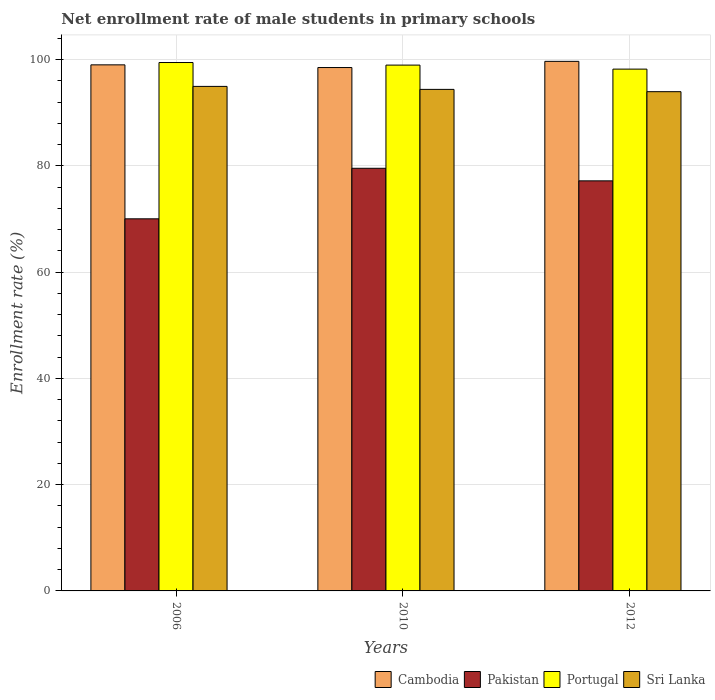How many different coloured bars are there?
Your answer should be very brief. 4. How many groups of bars are there?
Give a very brief answer. 3. Are the number of bars per tick equal to the number of legend labels?
Your answer should be very brief. Yes. How many bars are there on the 3rd tick from the left?
Your answer should be very brief. 4. How many bars are there on the 2nd tick from the right?
Your answer should be compact. 4. In how many cases, is the number of bars for a given year not equal to the number of legend labels?
Ensure brevity in your answer.  0. What is the net enrollment rate of male students in primary schools in Pakistan in 2006?
Offer a very short reply. 70.04. Across all years, what is the maximum net enrollment rate of male students in primary schools in Portugal?
Provide a succinct answer. 99.46. Across all years, what is the minimum net enrollment rate of male students in primary schools in Sri Lanka?
Make the answer very short. 93.97. In which year was the net enrollment rate of male students in primary schools in Portugal minimum?
Provide a succinct answer. 2012. What is the total net enrollment rate of male students in primary schools in Pakistan in the graph?
Offer a very short reply. 226.78. What is the difference between the net enrollment rate of male students in primary schools in Pakistan in 2006 and that in 2010?
Your response must be concise. -9.51. What is the difference between the net enrollment rate of male students in primary schools in Sri Lanka in 2010 and the net enrollment rate of male students in primary schools in Portugal in 2006?
Give a very brief answer. -5.06. What is the average net enrollment rate of male students in primary schools in Pakistan per year?
Provide a succinct answer. 75.59. In the year 2010, what is the difference between the net enrollment rate of male students in primary schools in Portugal and net enrollment rate of male students in primary schools in Sri Lanka?
Provide a succinct answer. 4.57. In how many years, is the net enrollment rate of male students in primary schools in Cambodia greater than 24 %?
Provide a succinct answer. 3. What is the ratio of the net enrollment rate of male students in primary schools in Sri Lanka in 2006 to that in 2012?
Offer a terse response. 1.01. Is the net enrollment rate of male students in primary schools in Sri Lanka in 2010 less than that in 2012?
Keep it short and to the point. No. Is the difference between the net enrollment rate of male students in primary schools in Portugal in 2010 and 2012 greater than the difference between the net enrollment rate of male students in primary schools in Sri Lanka in 2010 and 2012?
Ensure brevity in your answer.  Yes. What is the difference between the highest and the second highest net enrollment rate of male students in primary schools in Cambodia?
Provide a short and direct response. 0.66. What is the difference between the highest and the lowest net enrollment rate of male students in primary schools in Sri Lanka?
Keep it short and to the point. 0.99. Is the sum of the net enrollment rate of male students in primary schools in Sri Lanka in 2010 and 2012 greater than the maximum net enrollment rate of male students in primary schools in Cambodia across all years?
Your answer should be compact. Yes. What does the 2nd bar from the left in 2006 represents?
Ensure brevity in your answer.  Pakistan. What does the 1st bar from the right in 2010 represents?
Provide a succinct answer. Sri Lanka. Is it the case that in every year, the sum of the net enrollment rate of male students in primary schools in Portugal and net enrollment rate of male students in primary schools in Sri Lanka is greater than the net enrollment rate of male students in primary schools in Pakistan?
Keep it short and to the point. Yes. How many bars are there?
Your answer should be compact. 12. How many years are there in the graph?
Provide a short and direct response. 3. Does the graph contain any zero values?
Offer a terse response. No. What is the title of the graph?
Your response must be concise. Net enrollment rate of male students in primary schools. Does "United Arab Emirates" appear as one of the legend labels in the graph?
Offer a very short reply. No. What is the label or title of the Y-axis?
Provide a succinct answer. Enrollment rate (%). What is the Enrollment rate (%) of Cambodia in 2006?
Offer a terse response. 99.02. What is the Enrollment rate (%) in Pakistan in 2006?
Offer a very short reply. 70.04. What is the Enrollment rate (%) in Portugal in 2006?
Keep it short and to the point. 99.46. What is the Enrollment rate (%) of Sri Lanka in 2006?
Keep it short and to the point. 94.97. What is the Enrollment rate (%) in Cambodia in 2010?
Your answer should be compact. 98.52. What is the Enrollment rate (%) in Pakistan in 2010?
Provide a short and direct response. 79.55. What is the Enrollment rate (%) of Portugal in 2010?
Your response must be concise. 98.97. What is the Enrollment rate (%) in Sri Lanka in 2010?
Ensure brevity in your answer.  94.4. What is the Enrollment rate (%) of Cambodia in 2012?
Offer a very short reply. 99.68. What is the Enrollment rate (%) in Pakistan in 2012?
Your answer should be compact. 77.19. What is the Enrollment rate (%) in Portugal in 2012?
Ensure brevity in your answer.  98.22. What is the Enrollment rate (%) in Sri Lanka in 2012?
Give a very brief answer. 93.97. Across all years, what is the maximum Enrollment rate (%) of Cambodia?
Make the answer very short. 99.68. Across all years, what is the maximum Enrollment rate (%) of Pakistan?
Your answer should be compact. 79.55. Across all years, what is the maximum Enrollment rate (%) of Portugal?
Your answer should be very brief. 99.46. Across all years, what is the maximum Enrollment rate (%) in Sri Lanka?
Make the answer very short. 94.97. Across all years, what is the minimum Enrollment rate (%) in Cambodia?
Your response must be concise. 98.52. Across all years, what is the minimum Enrollment rate (%) in Pakistan?
Offer a terse response. 70.04. Across all years, what is the minimum Enrollment rate (%) of Portugal?
Your answer should be very brief. 98.22. Across all years, what is the minimum Enrollment rate (%) in Sri Lanka?
Provide a short and direct response. 93.97. What is the total Enrollment rate (%) of Cambodia in the graph?
Provide a short and direct response. 297.22. What is the total Enrollment rate (%) of Pakistan in the graph?
Give a very brief answer. 226.78. What is the total Enrollment rate (%) of Portugal in the graph?
Your answer should be very brief. 296.65. What is the total Enrollment rate (%) in Sri Lanka in the graph?
Offer a terse response. 283.34. What is the difference between the Enrollment rate (%) in Cambodia in 2006 and that in 2010?
Give a very brief answer. 0.51. What is the difference between the Enrollment rate (%) in Pakistan in 2006 and that in 2010?
Ensure brevity in your answer.  -9.51. What is the difference between the Enrollment rate (%) in Portugal in 2006 and that in 2010?
Make the answer very short. 0.49. What is the difference between the Enrollment rate (%) of Sri Lanka in 2006 and that in 2010?
Provide a succinct answer. 0.56. What is the difference between the Enrollment rate (%) in Cambodia in 2006 and that in 2012?
Keep it short and to the point. -0.66. What is the difference between the Enrollment rate (%) in Pakistan in 2006 and that in 2012?
Keep it short and to the point. -7.15. What is the difference between the Enrollment rate (%) of Portugal in 2006 and that in 2012?
Ensure brevity in your answer.  1.24. What is the difference between the Enrollment rate (%) of Sri Lanka in 2006 and that in 2012?
Make the answer very short. 0.99. What is the difference between the Enrollment rate (%) of Cambodia in 2010 and that in 2012?
Your response must be concise. -1.16. What is the difference between the Enrollment rate (%) in Pakistan in 2010 and that in 2012?
Your answer should be compact. 2.36. What is the difference between the Enrollment rate (%) in Portugal in 2010 and that in 2012?
Give a very brief answer. 0.76. What is the difference between the Enrollment rate (%) in Sri Lanka in 2010 and that in 2012?
Make the answer very short. 0.43. What is the difference between the Enrollment rate (%) in Cambodia in 2006 and the Enrollment rate (%) in Pakistan in 2010?
Give a very brief answer. 19.47. What is the difference between the Enrollment rate (%) in Cambodia in 2006 and the Enrollment rate (%) in Portugal in 2010?
Ensure brevity in your answer.  0.05. What is the difference between the Enrollment rate (%) of Cambodia in 2006 and the Enrollment rate (%) of Sri Lanka in 2010?
Your answer should be compact. 4.62. What is the difference between the Enrollment rate (%) in Pakistan in 2006 and the Enrollment rate (%) in Portugal in 2010?
Offer a terse response. -28.93. What is the difference between the Enrollment rate (%) of Pakistan in 2006 and the Enrollment rate (%) of Sri Lanka in 2010?
Keep it short and to the point. -24.36. What is the difference between the Enrollment rate (%) in Portugal in 2006 and the Enrollment rate (%) in Sri Lanka in 2010?
Provide a succinct answer. 5.06. What is the difference between the Enrollment rate (%) of Cambodia in 2006 and the Enrollment rate (%) of Pakistan in 2012?
Make the answer very short. 21.84. What is the difference between the Enrollment rate (%) of Cambodia in 2006 and the Enrollment rate (%) of Portugal in 2012?
Your answer should be compact. 0.8. What is the difference between the Enrollment rate (%) of Cambodia in 2006 and the Enrollment rate (%) of Sri Lanka in 2012?
Your answer should be compact. 5.05. What is the difference between the Enrollment rate (%) of Pakistan in 2006 and the Enrollment rate (%) of Portugal in 2012?
Keep it short and to the point. -28.18. What is the difference between the Enrollment rate (%) in Pakistan in 2006 and the Enrollment rate (%) in Sri Lanka in 2012?
Provide a short and direct response. -23.93. What is the difference between the Enrollment rate (%) of Portugal in 2006 and the Enrollment rate (%) of Sri Lanka in 2012?
Give a very brief answer. 5.49. What is the difference between the Enrollment rate (%) in Cambodia in 2010 and the Enrollment rate (%) in Pakistan in 2012?
Provide a short and direct response. 21.33. What is the difference between the Enrollment rate (%) in Cambodia in 2010 and the Enrollment rate (%) in Portugal in 2012?
Provide a succinct answer. 0.3. What is the difference between the Enrollment rate (%) of Cambodia in 2010 and the Enrollment rate (%) of Sri Lanka in 2012?
Make the answer very short. 4.54. What is the difference between the Enrollment rate (%) of Pakistan in 2010 and the Enrollment rate (%) of Portugal in 2012?
Offer a terse response. -18.67. What is the difference between the Enrollment rate (%) in Pakistan in 2010 and the Enrollment rate (%) in Sri Lanka in 2012?
Your answer should be very brief. -14.42. What is the difference between the Enrollment rate (%) of Portugal in 2010 and the Enrollment rate (%) of Sri Lanka in 2012?
Your response must be concise. 5. What is the average Enrollment rate (%) in Cambodia per year?
Your answer should be compact. 99.07. What is the average Enrollment rate (%) in Pakistan per year?
Offer a very short reply. 75.59. What is the average Enrollment rate (%) of Portugal per year?
Provide a short and direct response. 98.88. What is the average Enrollment rate (%) of Sri Lanka per year?
Ensure brevity in your answer.  94.45. In the year 2006, what is the difference between the Enrollment rate (%) of Cambodia and Enrollment rate (%) of Pakistan?
Offer a terse response. 28.98. In the year 2006, what is the difference between the Enrollment rate (%) in Cambodia and Enrollment rate (%) in Portugal?
Your answer should be compact. -0.44. In the year 2006, what is the difference between the Enrollment rate (%) of Cambodia and Enrollment rate (%) of Sri Lanka?
Ensure brevity in your answer.  4.06. In the year 2006, what is the difference between the Enrollment rate (%) in Pakistan and Enrollment rate (%) in Portugal?
Your answer should be very brief. -29.42. In the year 2006, what is the difference between the Enrollment rate (%) in Pakistan and Enrollment rate (%) in Sri Lanka?
Make the answer very short. -24.92. In the year 2006, what is the difference between the Enrollment rate (%) in Portugal and Enrollment rate (%) in Sri Lanka?
Provide a succinct answer. 4.5. In the year 2010, what is the difference between the Enrollment rate (%) of Cambodia and Enrollment rate (%) of Pakistan?
Keep it short and to the point. 18.97. In the year 2010, what is the difference between the Enrollment rate (%) in Cambodia and Enrollment rate (%) in Portugal?
Keep it short and to the point. -0.46. In the year 2010, what is the difference between the Enrollment rate (%) in Cambodia and Enrollment rate (%) in Sri Lanka?
Your answer should be compact. 4.11. In the year 2010, what is the difference between the Enrollment rate (%) of Pakistan and Enrollment rate (%) of Portugal?
Provide a short and direct response. -19.42. In the year 2010, what is the difference between the Enrollment rate (%) of Pakistan and Enrollment rate (%) of Sri Lanka?
Your answer should be very brief. -14.85. In the year 2010, what is the difference between the Enrollment rate (%) of Portugal and Enrollment rate (%) of Sri Lanka?
Ensure brevity in your answer.  4.57. In the year 2012, what is the difference between the Enrollment rate (%) of Cambodia and Enrollment rate (%) of Pakistan?
Offer a very short reply. 22.49. In the year 2012, what is the difference between the Enrollment rate (%) of Cambodia and Enrollment rate (%) of Portugal?
Provide a short and direct response. 1.46. In the year 2012, what is the difference between the Enrollment rate (%) of Cambodia and Enrollment rate (%) of Sri Lanka?
Make the answer very short. 5.71. In the year 2012, what is the difference between the Enrollment rate (%) of Pakistan and Enrollment rate (%) of Portugal?
Offer a very short reply. -21.03. In the year 2012, what is the difference between the Enrollment rate (%) in Pakistan and Enrollment rate (%) in Sri Lanka?
Your answer should be compact. -16.79. In the year 2012, what is the difference between the Enrollment rate (%) in Portugal and Enrollment rate (%) in Sri Lanka?
Give a very brief answer. 4.25. What is the ratio of the Enrollment rate (%) in Pakistan in 2006 to that in 2010?
Ensure brevity in your answer.  0.88. What is the ratio of the Enrollment rate (%) of Sri Lanka in 2006 to that in 2010?
Ensure brevity in your answer.  1.01. What is the ratio of the Enrollment rate (%) of Pakistan in 2006 to that in 2012?
Offer a terse response. 0.91. What is the ratio of the Enrollment rate (%) in Portugal in 2006 to that in 2012?
Ensure brevity in your answer.  1.01. What is the ratio of the Enrollment rate (%) of Sri Lanka in 2006 to that in 2012?
Provide a succinct answer. 1.01. What is the ratio of the Enrollment rate (%) in Cambodia in 2010 to that in 2012?
Keep it short and to the point. 0.99. What is the ratio of the Enrollment rate (%) in Pakistan in 2010 to that in 2012?
Keep it short and to the point. 1.03. What is the ratio of the Enrollment rate (%) in Portugal in 2010 to that in 2012?
Offer a terse response. 1.01. What is the difference between the highest and the second highest Enrollment rate (%) of Cambodia?
Give a very brief answer. 0.66. What is the difference between the highest and the second highest Enrollment rate (%) in Pakistan?
Provide a succinct answer. 2.36. What is the difference between the highest and the second highest Enrollment rate (%) of Portugal?
Keep it short and to the point. 0.49. What is the difference between the highest and the second highest Enrollment rate (%) of Sri Lanka?
Your response must be concise. 0.56. What is the difference between the highest and the lowest Enrollment rate (%) of Cambodia?
Your response must be concise. 1.16. What is the difference between the highest and the lowest Enrollment rate (%) of Pakistan?
Make the answer very short. 9.51. What is the difference between the highest and the lowest Enrollment rate (%) of Portugal?
Keep it short and to the point. 1.24. What is the difference between the highest and the lowest Enrollment rate (%) of Sri Lanka?
Provide a succinct answer. 0.99. 